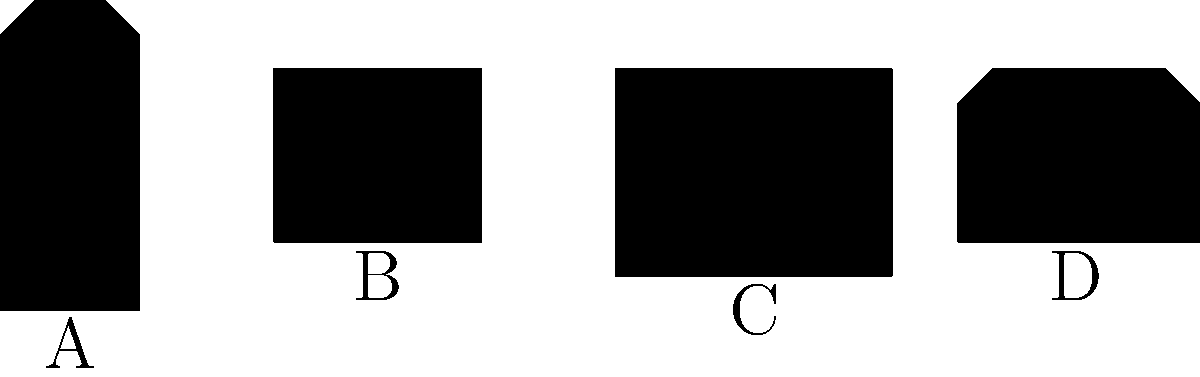Identify the medical equipment represented by silhouette B in the image above, which is commonly used in the ICU for precise medication administration. To identify the medical equipment represented by silhouette B, let's analyze each silhouette:

1. Silhouette A: This shape represents a ventilator, characterized by its tall, rectangular body with a slightly angled top.

2. Silhouette B: This shape shows a compact, rectangular device. Its small size and box-like appearance are typical of an IV (Intravenous) pump.

3. Silhouette C: This larger, rectangular shape with a wider screen area represents an ECG (Electrocardiogram) monitor.

4. Silhouette D: This shape, with its distinctive handle-like top, represents a defibrillator.

Given the question's focus on precise medication administration in the ICU, the correct answer is silhouette B, which represents an IV pump. IV pumps are crucial in ICU settings for delivering accurate doses of medications, fluids, and nutrients to patients.
Answer: IV pump 